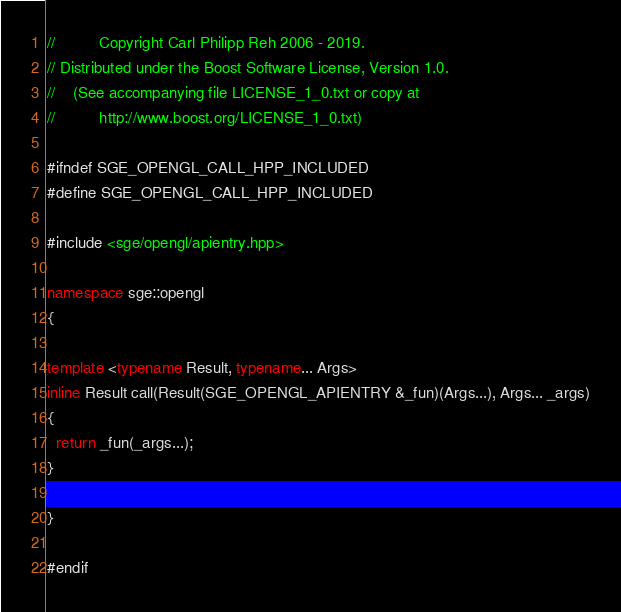Convert code to text. <code><loc_0><loc_0><loc_500><loc_500><_C++_>//          Copyright Carl Philipp Reh 2006 - 2019.
// Distributed under the Boost Software License, Version 1.0.
//    (See accompanying file LICENSE_1_0.txt or copy at
//          http://www.boost.org/LICENSE_1_0.txt)

#ifndef SGE_OPENGL_CALL_HPP_INCLUDED
#define SGE_OPENGL_CALL_HPP_INCLUDED

#include <sge/opengl/apientry.hpp>

namespace sge::opengl
{

template <typename Result, typename... Args>
inline Result call(Result(SGE_OPENGL_APIENTRY &_fun)(Args...), Args... _args)
{
  return _fun(_args...);
}

}

#endif
</code> 